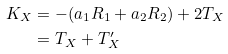Convert formula to latex. <formula><loc_0><loc_0><loc_500><loc_500>K _ { X } & = - ( a _ { 1 } R _ { 1 } + a _ { 2 } R _ { 2 } ) + 2 T _ { X } \\ & = T _ { X } + T _ { X } ^ { \prime }</formula> 